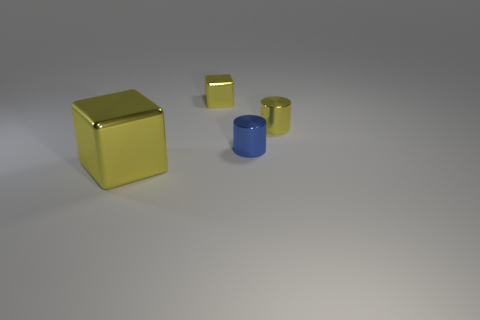This image seems composed. What could be the purpose of such a composition? The composition may be intended for a variety of purposes such as a product showcase, a study in color contrast and object relationships, or an example for educational content discussing shapes, materials, or 3D rendering techniques. 